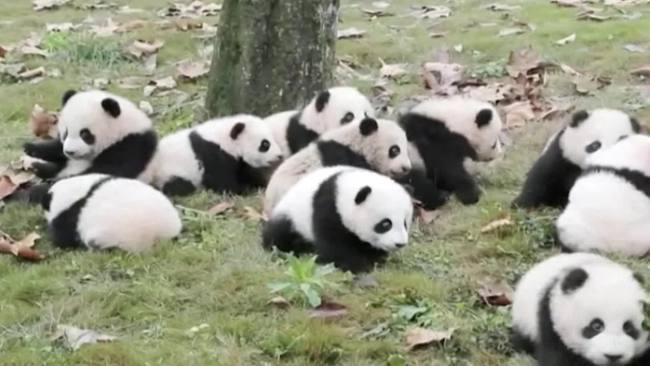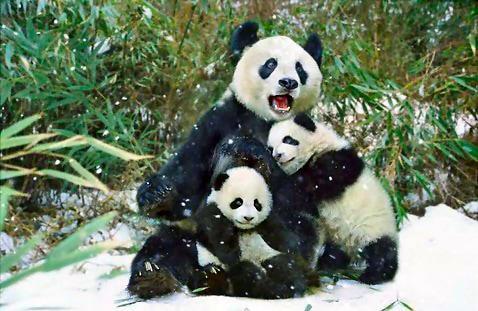The first image is the image on the left, the second image is the image on the right. For the images shown, is this caption "The left image contains baby pandas sleeping on a pink blanket." true? Answer yes or no. No. The first image is the image on the left, the second image is the image on the right. Evaluate the accuracy of this statement regarding the images: "An image shows rows of pandas sleeping on a pink blanket surrounded by rails, and a green ball is next to the blanket.". Is it true? Answer yes or no. No. 